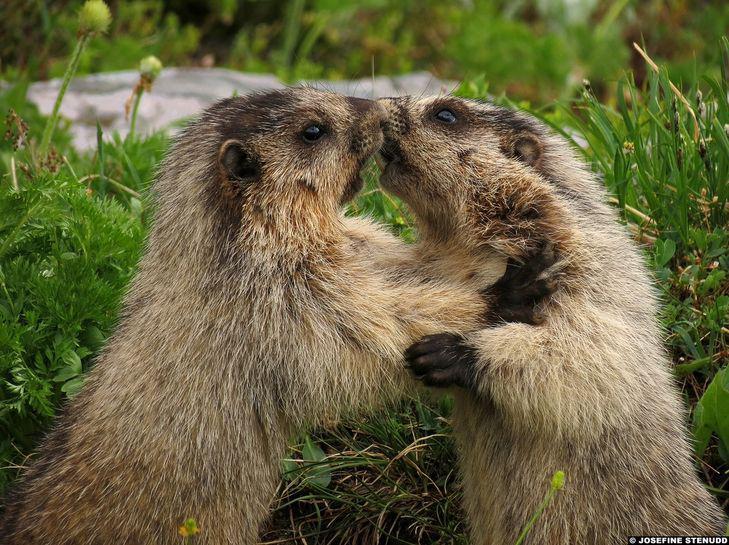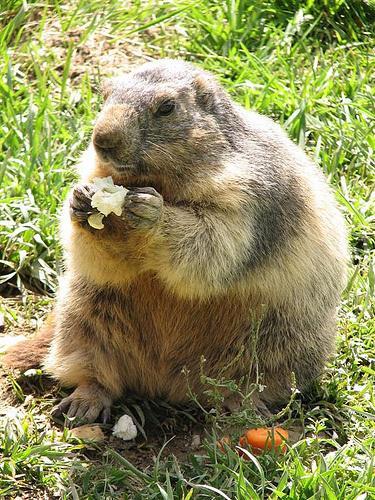The first image is the image on the left, the second image is the image on the right. Given the left and right images, does the statement "The image on the right shows a single marmot standing on its back legs eating food." hold true? Answer yes or no. Yes. The first image is the image on the left, the second image is the image on the right. For the images displayed, is the sentence "In one image, an animal is eating." factually correct? Answer yes or no. Yes. 